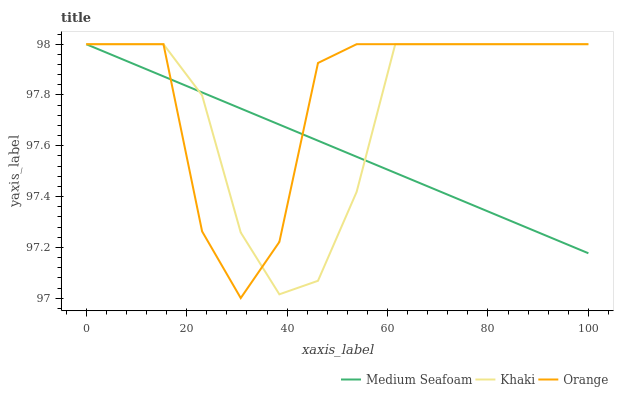Does Medium Seafoam have the minimum area under the curve?
Answer yes or no. Yes. Does Orange have the maximum area under the curve?
Answer yes or no. Yes. Does Khaki have the minimum area under the curve?
Answer yes or no. No. Does Khaki have the maximum area under the curve?
Answer yes or no. No. Is Medium Seafoam the smoothest?
Answer yes or no. Yes. Is Orange the roughest?
Answer yes or no. Yes. Is Khaki the smoothest?
Answer yes or no. No. Is Khaki the roughest?
Answer yes or no. No. Does Khaki have the lowest value?
Answer yes or no. No. Does Medium Seafoam have the highest value?
Answer yes or no. Yes. Does Khaki intersect Orange?
Answer yes or no. Yes. Is Khaki less than Orange?
Answer yes or no. No. Is Khaki greater than Orange?
Answer yes or no. No. 